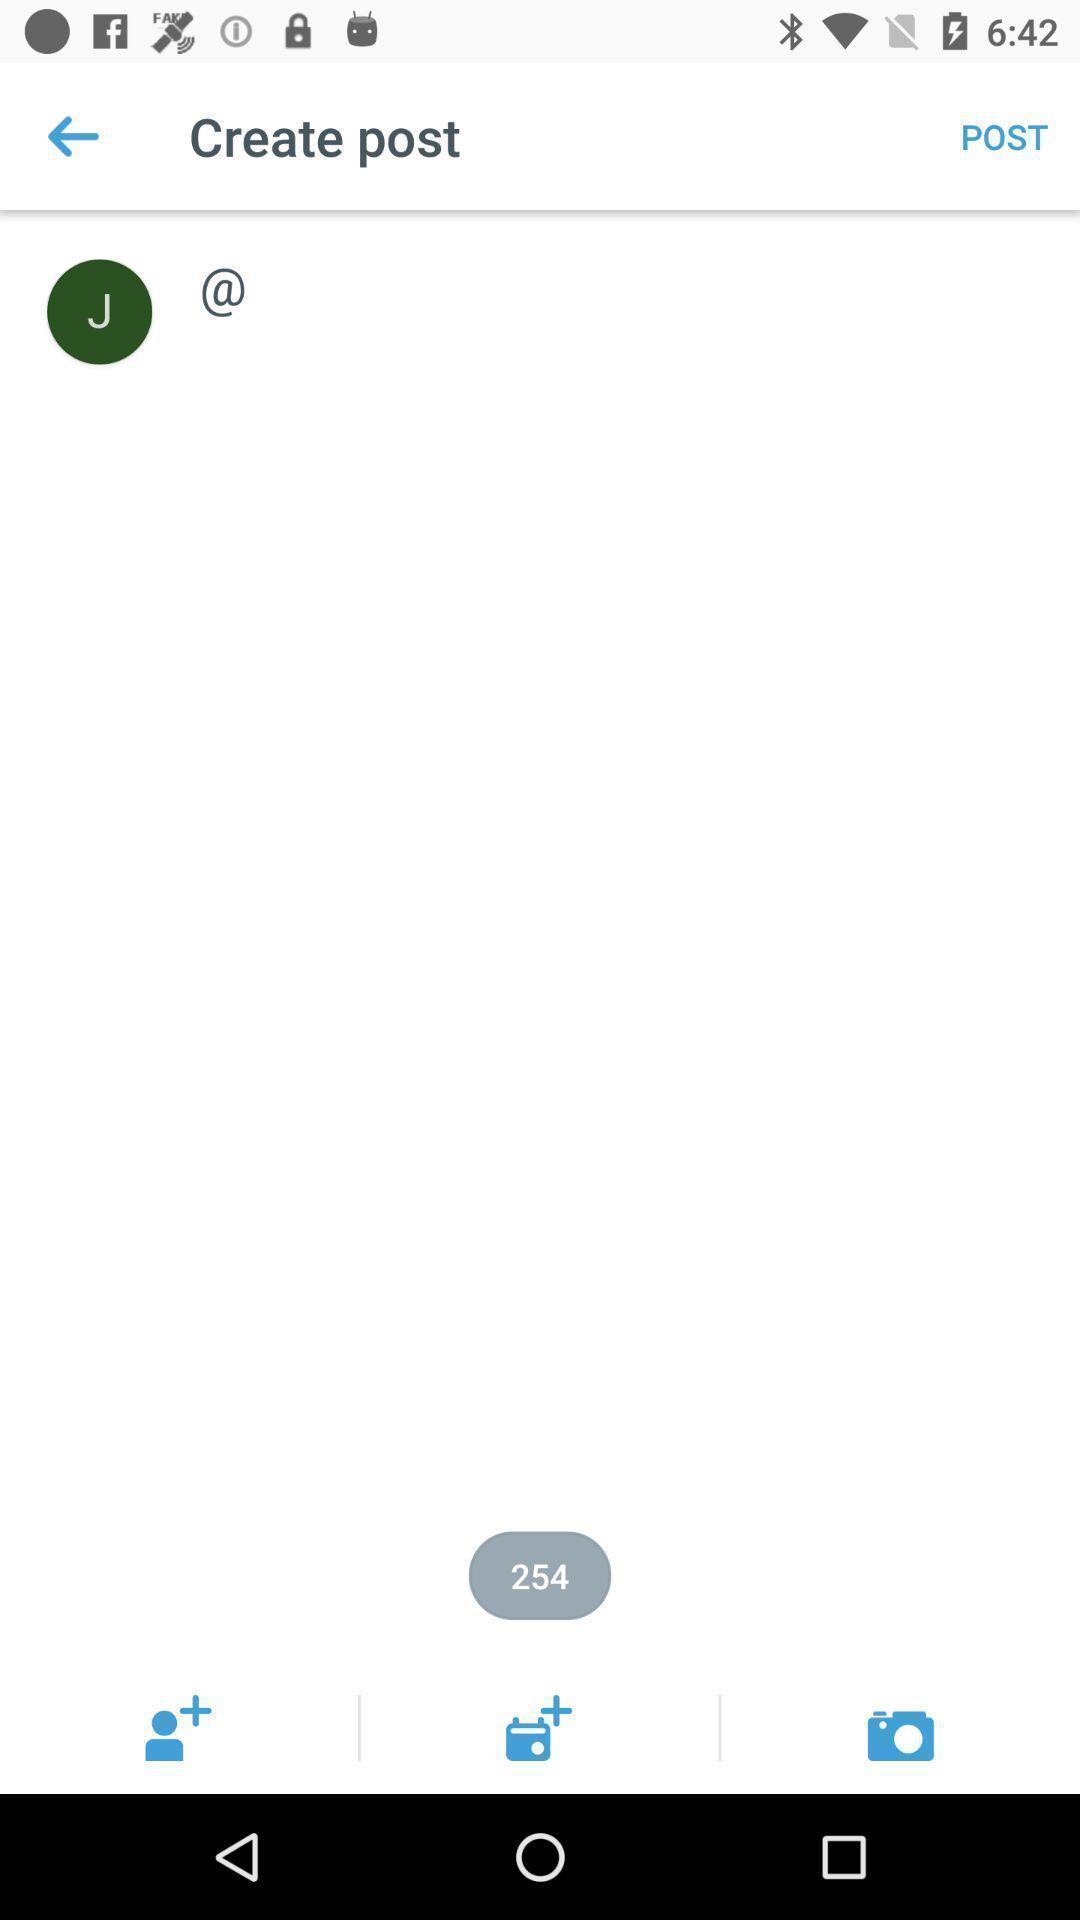Tell me what you see in this picture. Page displaying a post on social app. 